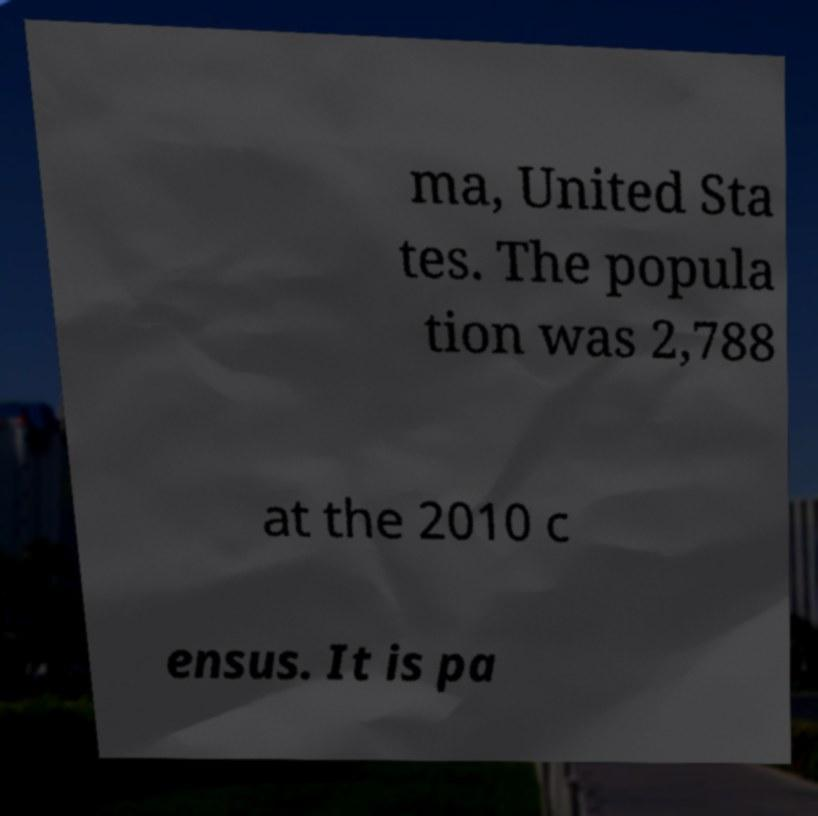Please identify and transcribe the text found in this image. ma, United Sta tes. The popula tion was 2,788 at the 2010 c ensus. It is pa 